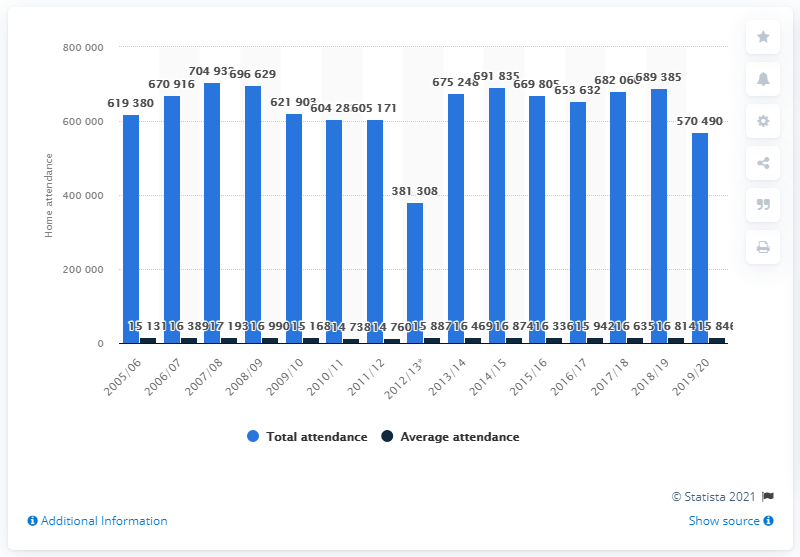Give some essential details in this illustration. The last season of the Anaheim Ducks in the National Hockey League was 2005/2006. 